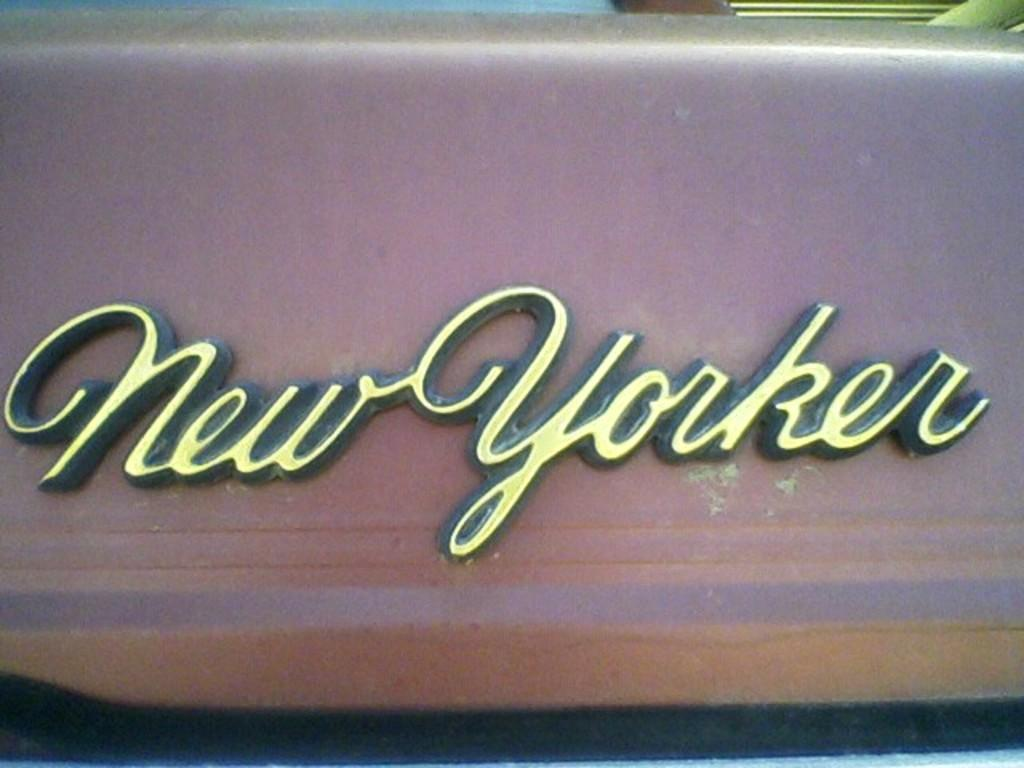What can be seen on the surface in the image? There is text visible on a surface in the image. What type of linen is being discussed in the image? There is no linen or discussion present in the image; it only features text on a surface. 